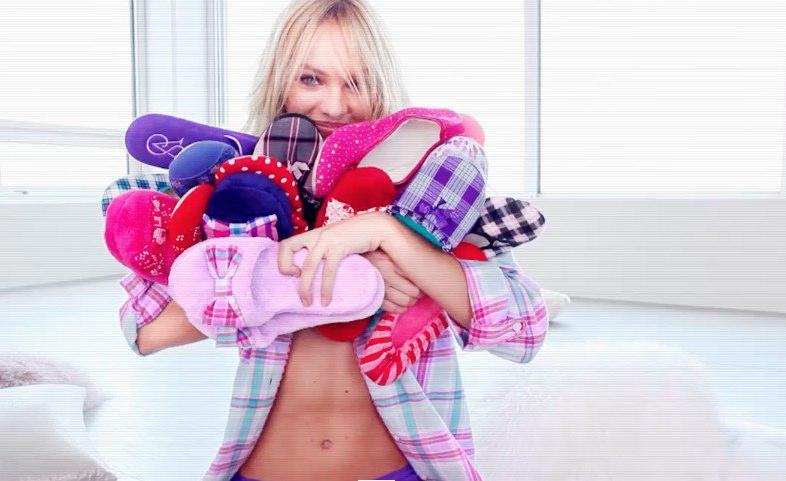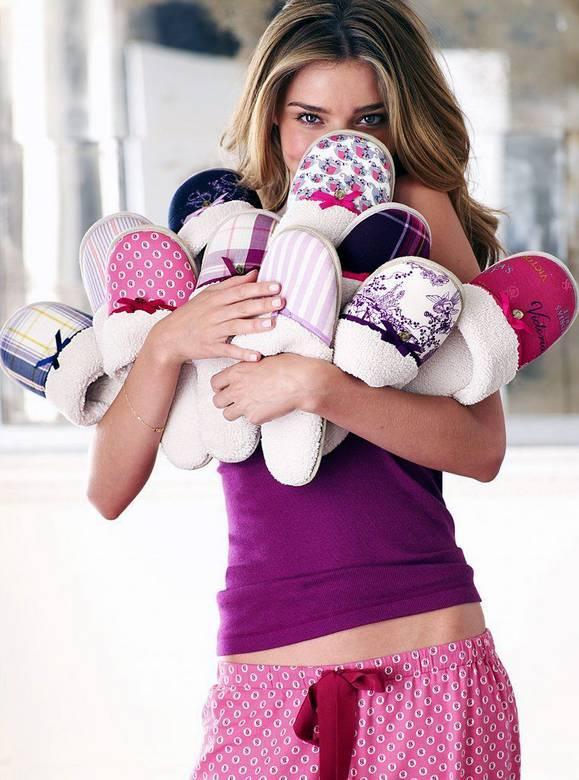The first image is the image on the left, the second image is the image on the right. Evaluate the accuracy of this statement regarding the images: "At least one image in the pair shows a woman in pyjamas holding a lot of slippers.". Is it true? Answer yes or no. Yes. The first image is the image on the left, the second image is the image on the right. Examine the images to the left and right. Is the description "A woman is holding an armload of slippers in at least one of the images." accurate? Answer yes or no. Yes. 